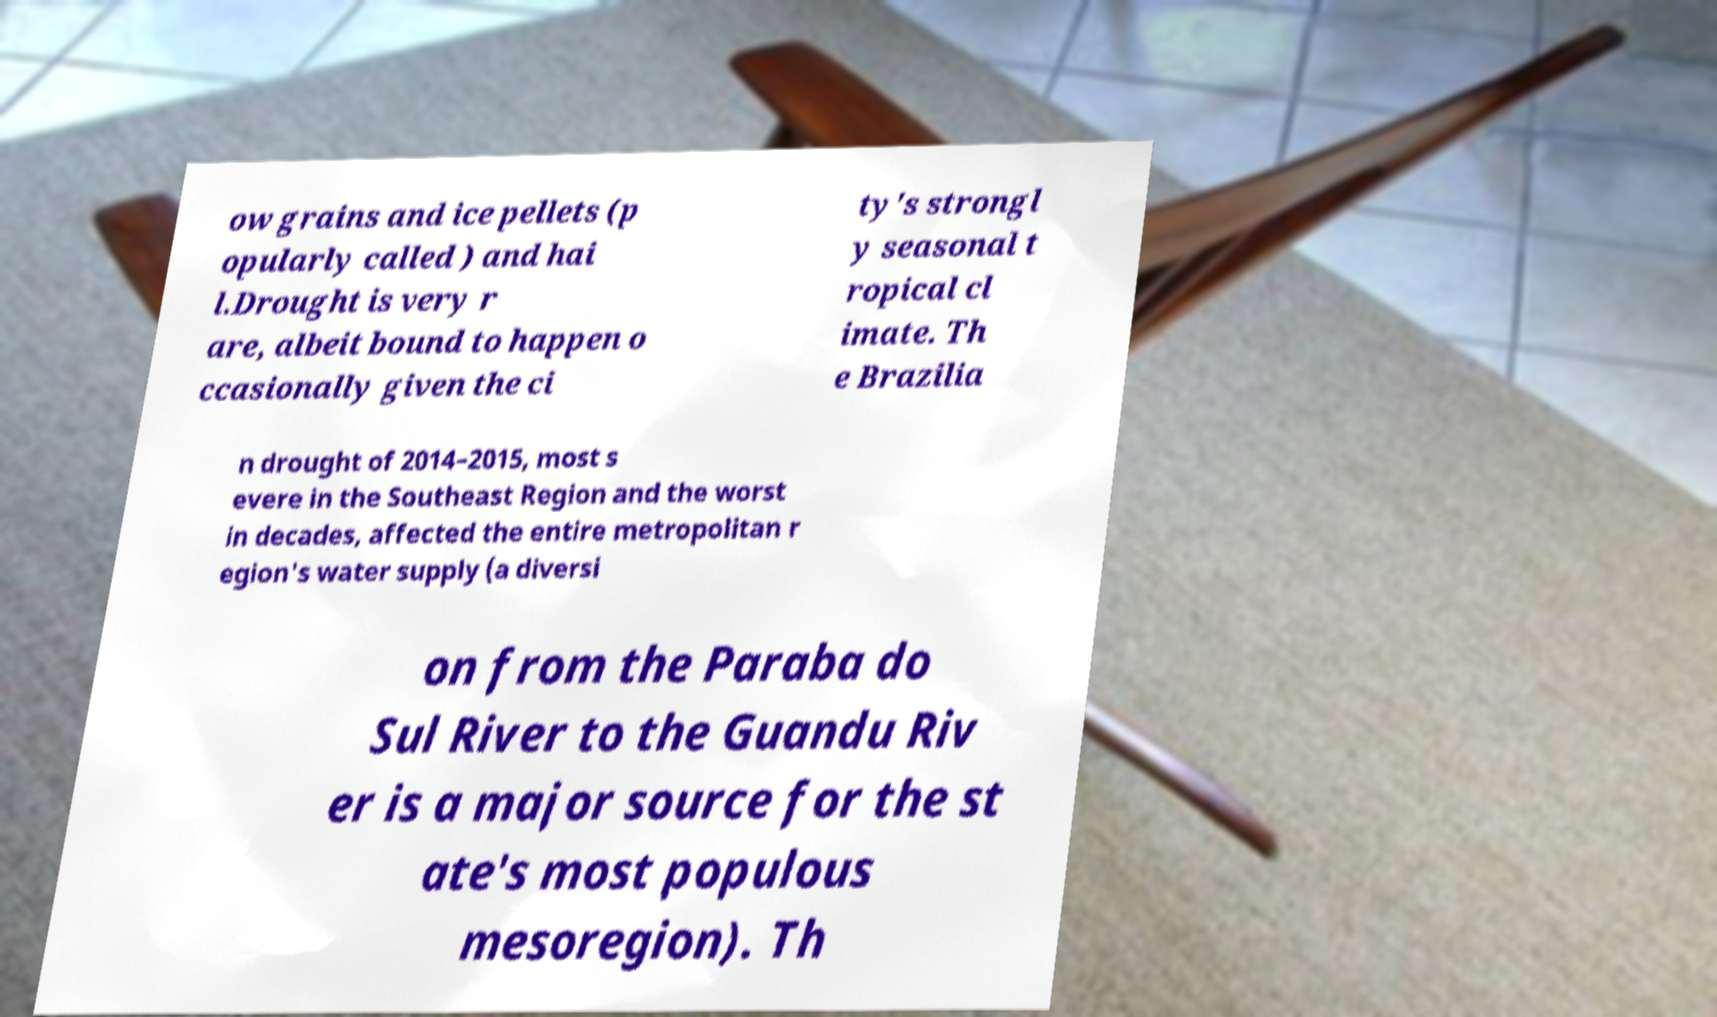What messages or text are displayed in this image? I need them in a readable, typed format. ow grains and ice pellets (p opularly called ) and hai l.Drought is very r are, albeit bound to happen o ccasionally given the ci ty's strongl y seasonal t ropical cl imate. Th e Brazilia n drought of 2014–2015, most s evere in the Southeast Region and the worst in decades, affected the entire metropolitan r egion's water supply (a diversi on from the Paraba do Sul River to the Guandu Riv er is a major source for the st ate's most populous mesoregion). Th 